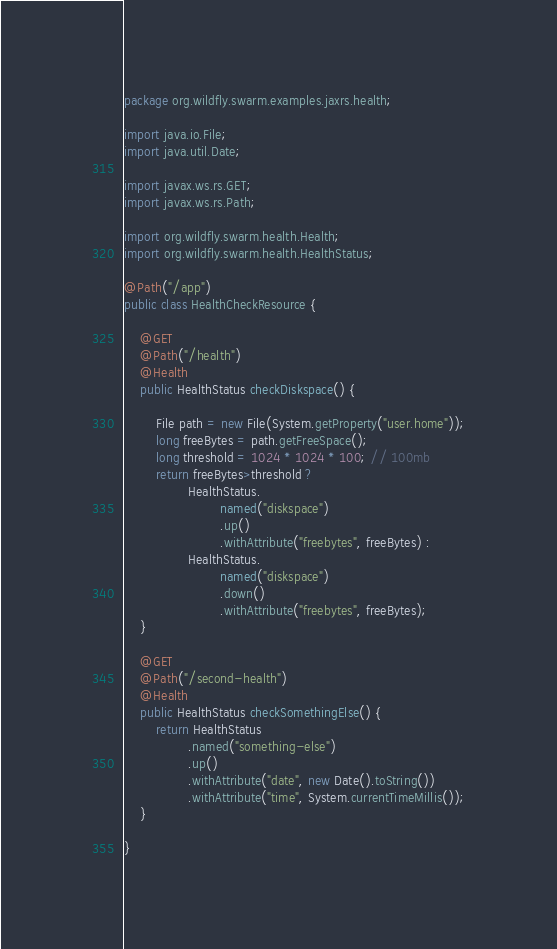Convert code to text. <code><loc_0><loc_0><loc_500><loc_500><_Java_>package org.wildfly.swarm.examples.jaxrs.health;

import java.io.File;
import java.util.Date;

import javax.ws.rs.GET;
import javax.ws.rs.Path;

import org.wildfly.swarm.health.Health;
import org.wildfly.swarm.health.HealthStatus;

@Path("/app")
public class HealthCheckResource {

    @GET
    @Path("/health")
    @Health
    public HealthStatus checkDiskspace() {

        File path = new File(System.getProperty("user.home"));
        long freeBytes = path.getFreeSpace();
        long threshold = 1024 * 1024 * 100; // 100mb
        return freeBytes>threshold ?
                HealthStatus.
                        named("diskspace")
                        .up()
                        .withAttribute("freebytes", freeBytes) :
                HealthStatus.
                        named("diskspace")
                        .down()
                        .withAttribute("freebytes", freeBytes);
    }

    @GET
    @Path("/second-health")
    @Health
    public HealthStatus checkSomethingElse() {
        return HealthStatus
                .named("something-else")
                .up()
                .withAttribute("date", new Date().toString())
                .withAttribute("time", System.currentTimeMillis());
    }

}
</code> 